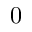<formula> <loc_0><loc_0><loc_500><loc_500>0</formula> 